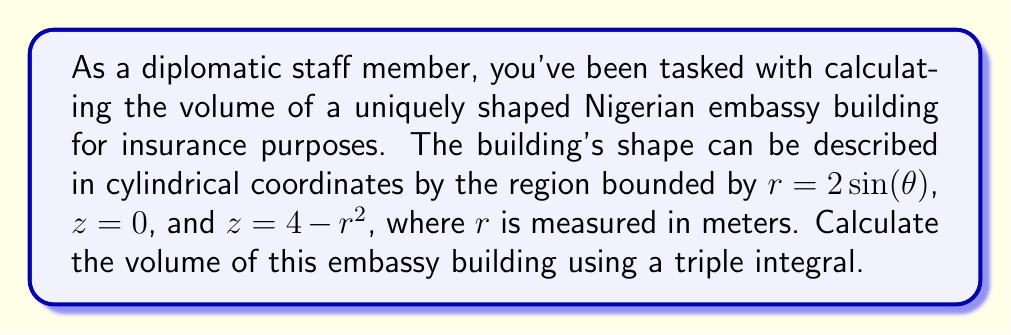Teach me how to tackle this problem. To solve this problem, we'll use a triple integral in cylindrical coordinates. The steps are as follows:

1) In cylindrical coordinates, the volume is given by the integral:

   $$V = \iiint_R r \, dr \, d\theta \, dz$$

2) We need to determine the limits of integration:
   - For $\theta$: The curve $r = 2\sin(\theta)$ traces out a full circle as $\theta$ goes from $0$ to $2\pi$.
   - For $r$: It ranges from $0$ to $2\sin(\theta)$.
   - For $z$: It goes from $0$ to $4 - r^2$.

3) Setting up the triple integral:

   $$V = \int_0^{2\pi} \int_0^{2\sin(\theta)} \int_0^{4-r^2} r \, dz \, dr \, d\theta$$

4) Evaluate the innermost integral (with respect to $z$):

   $$V = \int_0^{2\pi} \int_0^{2\sin(\theta)} r(4-r^2) \, dr \, d\theta$$

5) Evaluate the integral with respect to $r$:

   $$V = \int_0^{2\pi} \left[ 2r^2 - \frac{r^4}{4} \right]_0^{2\sin(\theta)} d\theta$$
   
   $$= \int_0^{2\pi} \left( 8\sin^2(\theta) - 4\sin^4(\theta) \right) d\theta$$

6) To evaluate this, we can use the identities:
   $\sin^2(\theta) = \frac{1-\cos(2\theta)}{2}$ and $\sin^4(\theta) = \frac{3-4\cos(2\theta)+\cos(4\theta)}{8}$

7) Substituting and simplifying:

   $$V = \int_0^{2\pi} \left( 8 \cdot \frac{1-\cos(2\theta)}{2} - 4 \cdot \frac{3-4\cos(2\theta)+\cos(4\theta)}{8} \right) d\theta$$
   
   $$= \int_0^{2\pi} \left( 4 - 4\cos(2\theta) - \frac{3}{2} + 2\cos(2\theta) - \frac{1}{2}\cos(4\theta) \right) d\theta$$
   
   $$= \int_0^{2\pi} \left( \frac{5}{2} - 2\cos(2\theta) - \frac{1}{2}\cos(4\theta) \right) d\theta$$

8) Evaluating this integral:

   $$V = \left[ \frac{5}{2}\theta - \sin(2\theta) - \frac{1}{8}\sin(4\theta) \right]_0^{2\pi}$$
   
   $$= 5\pi - 0 - 0 = 5\pi$$

Therefore, the volume of the embassy building is $5\pi$ cubic meters.
Answer: $5\pi$ cubic meters 